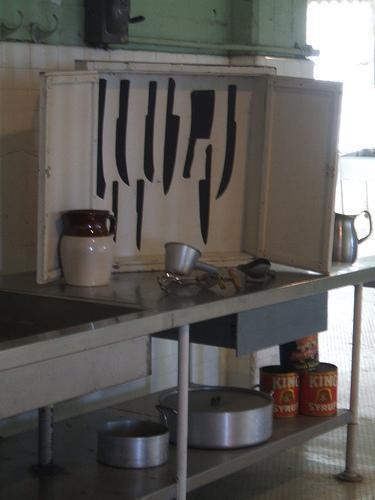Which one of these vegetables is used in the manufacture of the item in the cans?
Pick the right solution, then justify: 'Answer: answer
Rationale: rationale.'
Options: Eggplant, tomato, corn, pumpkin. Answer: corn.
Rationale: The cans under the counter contain corn syrup that is made from corn. 